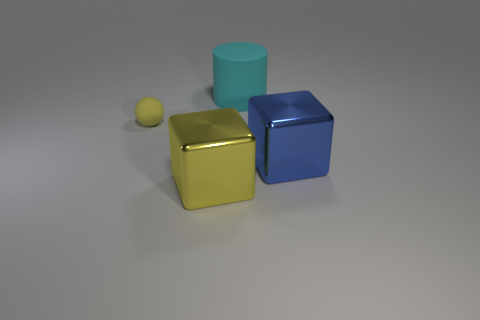What number of blocks have the same color as the small ball?
Provide a short and direct response. 1. Do the large block that is on the left side of the cyan object and the ball have the same color?
Keep it short and to the point. Yes. How many other objects are the same size as the cyan cylinder?
Your answer should be very brief. 2. Is the large yellow cube made of the same material as the tiny sphere?
Give a very brief answer. No. The object that is in front of the metallic thing that is right of the big rubber thing is what color?
Give a very brief answer. Yellow. What is the size of the blue shiny thing that is the same shape as the big yellow metal object?
Your response must be concise. Large. What number of big things are left of the large yellow metallic object that is left of the shiny cube that is to the right of the big yellow object?
Your answer should be very brief. 0. Is the number of large yellow metallic things greater than the number of gray spheres?
Provide a short and direct response. Yes. What number of yellow cubes are there?
Your response must be concise. 1. There is a big object behind the yellow object behind the yellow object that is right of the tiny yellow matte thing; what is its shape?
Your answer should be very brief. Cylinder. 